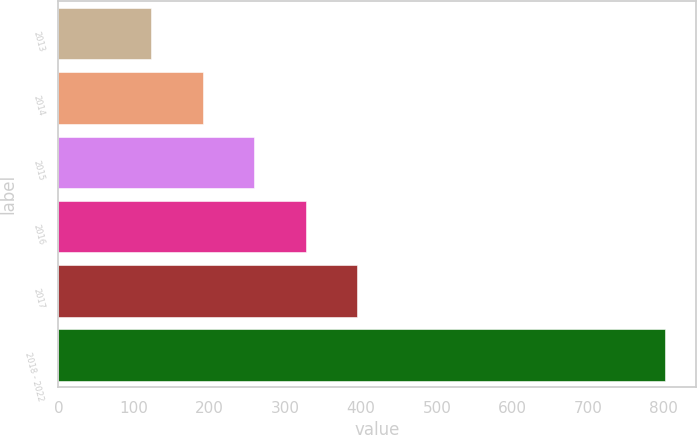<chart> <loc_0><loc_0><loc_500><loc_500><bar_chart><fcel>2013<fcel>2014<fcel>2015<fcel>2016<fcel>2017<fcel>2018 - 2022<nl><fcel>123<fcel>190.9<fcel>258.8<fcel>326.7<fcel>394.6<fcel>802<nl></chart> 